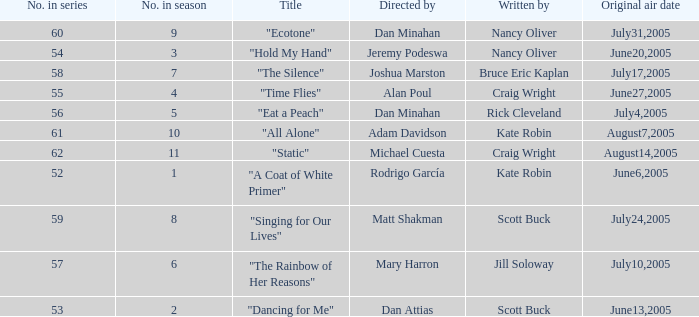What was the name of the episode that was directed by Mary Harron? "The Rainbow of Her Reasons". 